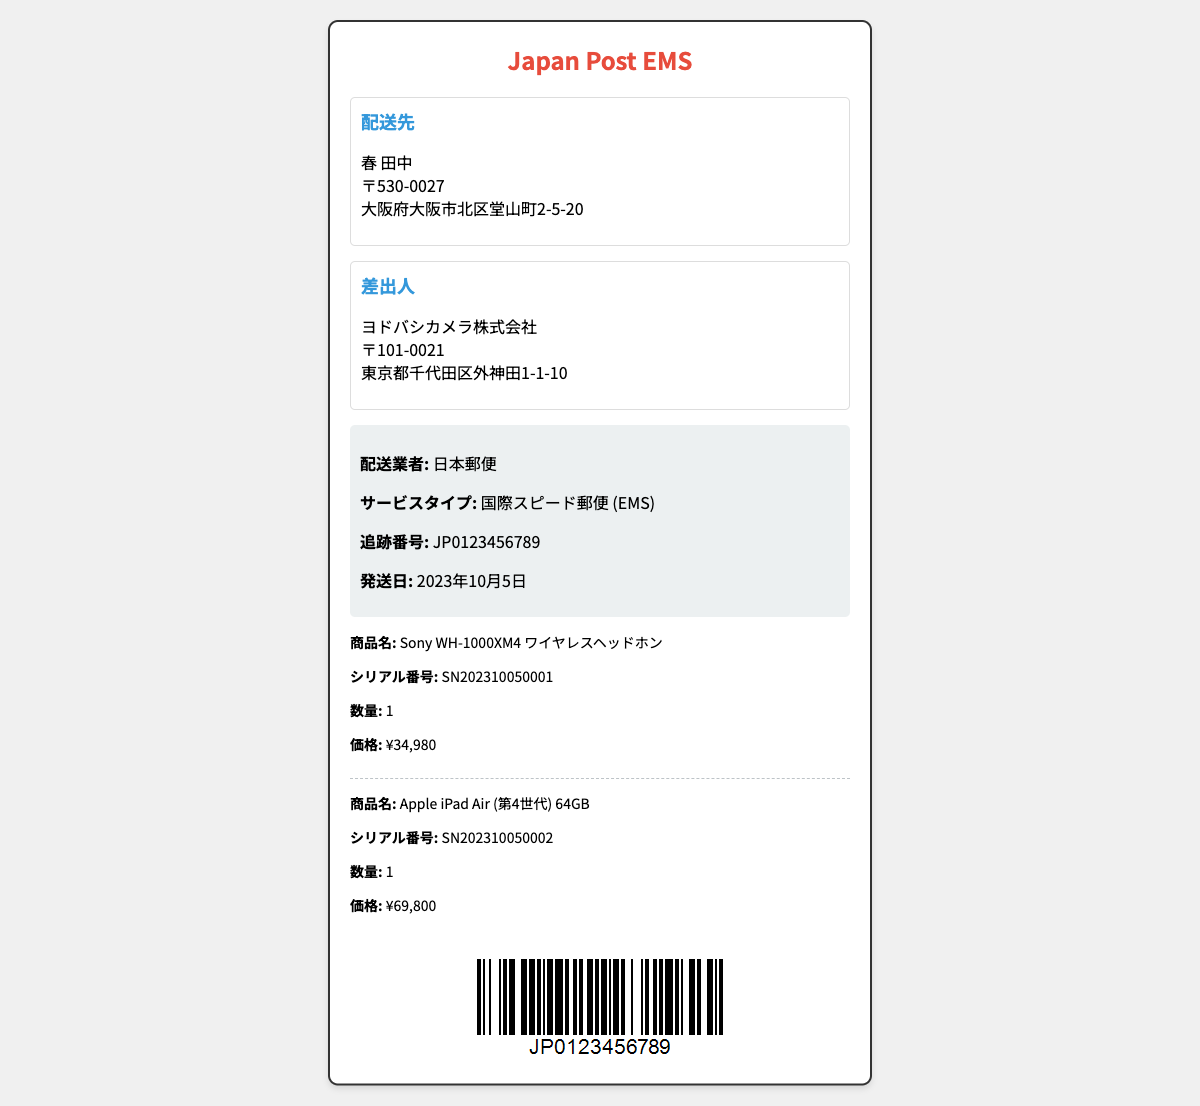What is the recipient's name? The name of the recipient is provided in the address section of the document, which states "春 田中".
Answer: 春 田中 What is the tracking number? The tracking number is listed under shipping details, which can be found in the document.
Answer: JP0123456789 What is the price of the Sony headphones? The price of the Sony WH-1000XM4 wireless headphones is given in the purchase details section.
Answer: ¥34,980 When was the item shipped? The shipping date is indicated in the shipping details part of the document.
Answer: 2023年10月5日 How many items are there in total? The purchase details section lists two items, thus the total count is derived from there.
Answer: 2 What is the service type used for shipping? The service type can be found in the shipping details section of the document.
Answer: 国際スピード郵便 (EMS) What is the sender's company name? The sender information section of the document includes the company name which is "ヨドバシカメラ株式会社".
Answer: ヨドバシカメラ株式会社 What is the serial number of the iPad? The serial number for the Apple iPad Air is listed in the purchase details for that item.
Answer: SN202310050002 Which city is the recipient located in? The city of the recipient can be inferred from the address provided in the document, specifically in the recipient's section.
Answer: 大阪市 